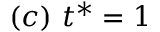Convert formula to latex. <formula><loc_0><loc_0><loc_500><loc_500>( c ) \ t ^ { * } = 1</formula> 